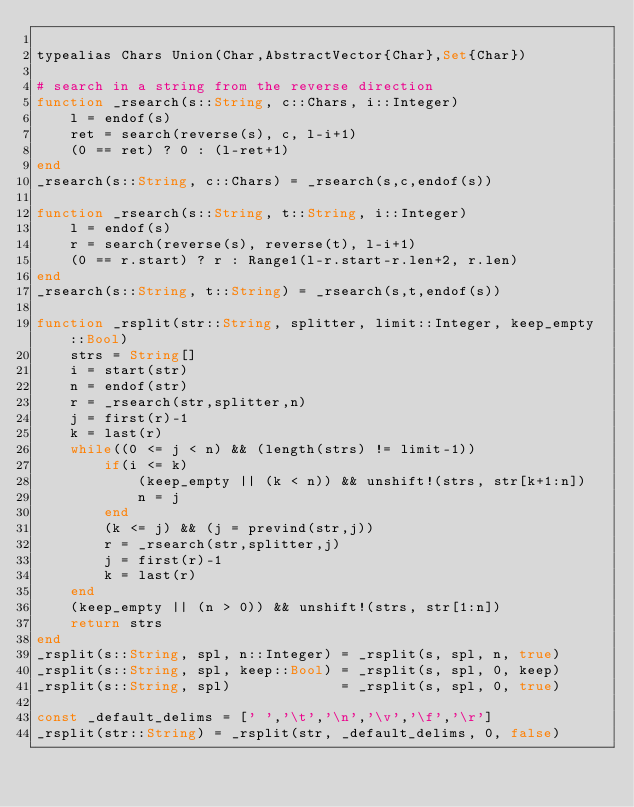Convert code to text. <code><loc_0><loc_0><loc_500><loc_500><_Julia_>
typealias Chars Union(Char,AbstractVector{Char},Set{Char})

# search in a string from the reverse direction
function _rsearch(s::String, c::Chars, i::Integer)
    l = endof(s)
    ret = search(reverse(s), c, l-i+1)
    (0 == ret) ? 0 : (l-ret+1)
end
_rsearch(s::String, c::Chars) = _rsearch(s,c,endof(s))

function _rsearch(s::String, t::String, i::Integer)
    l = endof(s)
    r = search(reverse(s), reverse(t), l-i+1)
    (0 == r.start) ? r : Range1(l-r.start-r.len+2, r.len)
end
_rsearch(s::String, t::String) = _rsearch(s,t,endof(s))

function _rsplit(str::String, splitter, limit::Integer, keep_empty::Bool)
    strs = String[]
    i = start(str)
    n = endof(str)
    r = _rsearch(str,splitter,n)
    j = first(r)-1 
    k = last(r)
    while((0 <= j < n) && (length(strs) != limit-1))
        if(i <= k)
            (keep_empty || (k < n)) && unshift!(strs, str[k+1:n])
            n = j
        end
        (k <= j) && (j = prevind(str,j))
        r = _rsearch(str,splitter,j)
        j = first(r)-1
        k = last(r)
    end
    (keep_empty || (n > 0)) && unshift!(strs, str[1:n])
    return strs
end
_rsplit(s::String, spl, n::Integer) = _rsplit(s, spl, n, true)
_rsplit(s::String, spl, keep::Bool) = _rsplit(s, spl, 0, keep)
_rsplit(s::String, spl)             = _rsplit(s, spl, 0, true)

const _default_delims = [' ','\t','\n','\v','\f','\r']
_rsplit(str::String) = _rsplit(str, _default_delims, 0, false)

</code> 